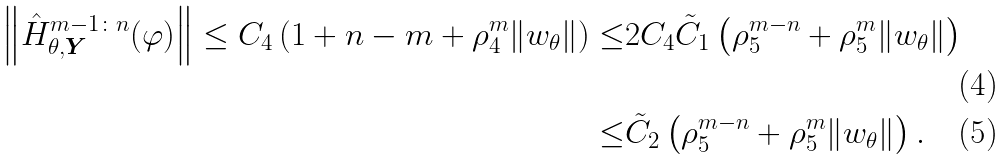<formula> <loc_0><loc_0><loc_500><loc_500>\left \| \hat { H } _ { \theta , \boldsymbol Y } ^ { m - 1 \colon n } ( \varphi ) \right \| \leq C _ { 4 } \left ( 1 + n - m + \rho _ { 4 } ^ { m } \| w _ { \theta } \| \right ) \leq & 2 C _ { 4 } \tilde { C } _ { 1 } \left ( \rho _ { 5 } ^ { m - n } + \rho _ { 5 } ^ { m } \| w _ { \theta } \| \right ) \\ \leq & \tilde { C } _ { 2 } \left ( \rho _ { 5 } ^ { m - n } + \rho _ { 5 } ^ { m } \| w _ { \theta } \| \right ) .</formula> 